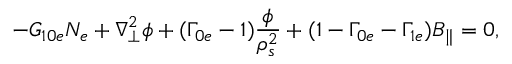<formula> <loc_0><loc_0><loc_500><loc_500>- G _ { 1 0 e } N _ { e } + \nabla _ { \perp } ^ { 2 } \phi + ( \Gamma _ { 0 e } - 1 ) \frac { \phi } { \rho _ { s } ^ { 2 } } + ( 1 - \Gamma _ { 0 e } - \Gamma _ { 1 e } ) B _ { \| } = 0 ,</formula> 